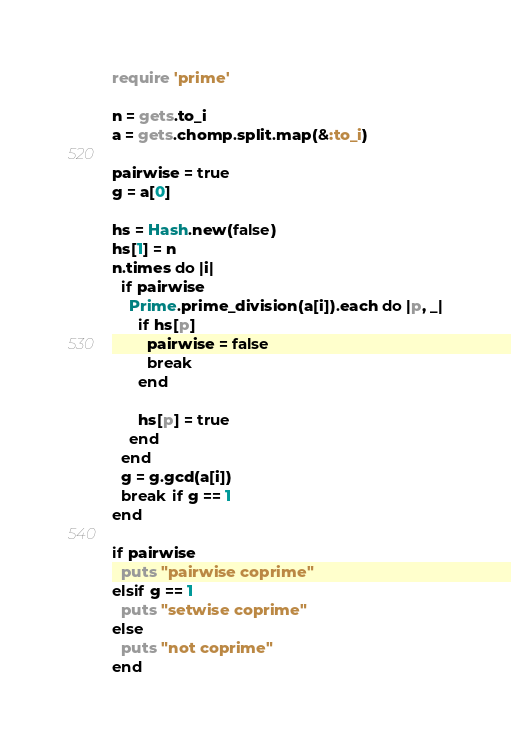Convert code to text. <code><loc_0><loc_0><loc_500><loc_500><_Ruby_>require 'prime'

n = gets.to_i
a = gets.chomp.split.map(&:to_i)

pairwise = true
g = a[0]

hs = Hash.new(false)
hs[1] = n
n.times do |i|
  if pairwise
    Prime.prime_division(a[i]).each do |p, _|
      if hs[p]
        pairwise = false
        break
      end
        
      hs[p] = true
    end
  end
  g = g.gcd(a[i])
  break if g == 1
end

if pairwise
  puts "pairwise coprime"
elsif g == 1
  puts "setwise coprime"
else
  puts "not coprime"
end
</code> 